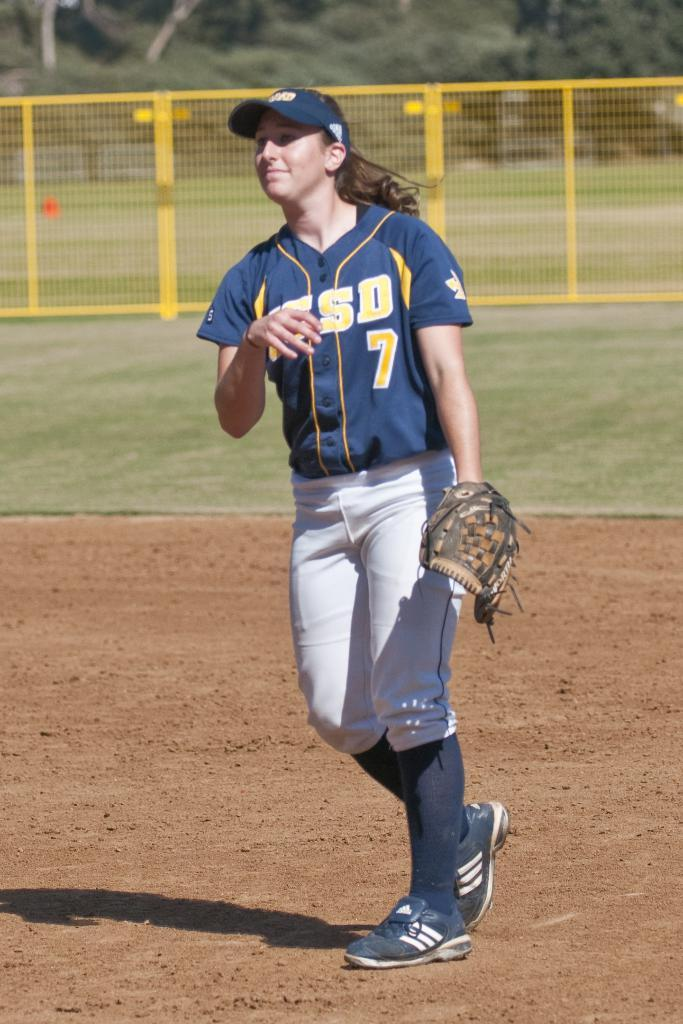Provide a one-sentence caption for the provided image. A girl wearing a blue and yellow softball jersey with the number 7 on it stands in the dirt on a softball field. 